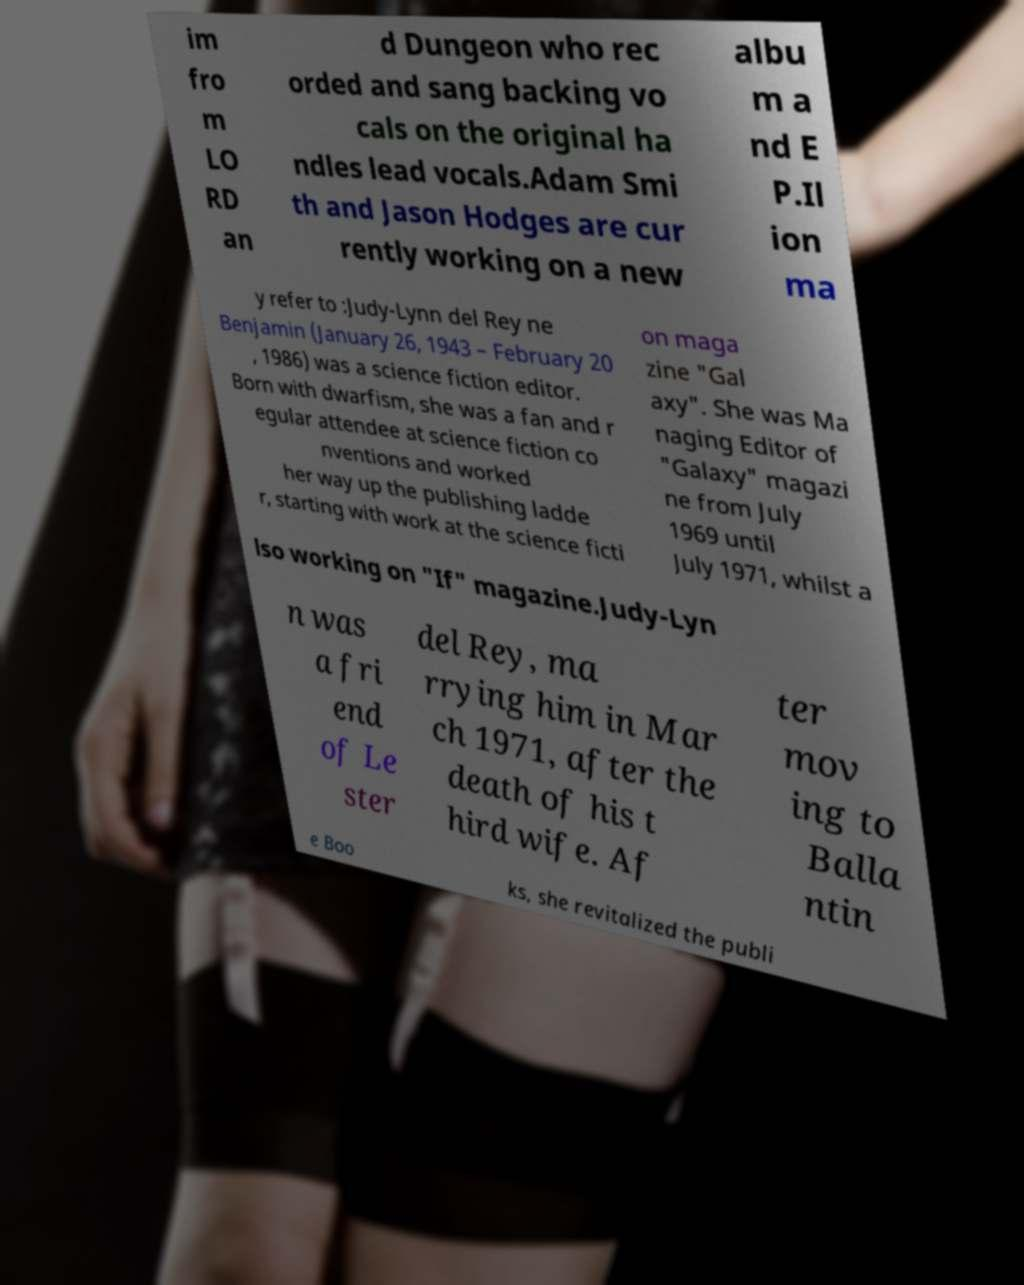Please identify and transcribe the text found in this image. im fro m LO RD an d Dungeon who rec orded and sang backing vo cals on the original ha ndles lead vocals.Adam Smi th and Jason Hodges are cur rently working on a new albu m a nd E P.Il ion ma y refer to :Judy-Lynn del Rey ne Benjamin (January 26, 1943 – February 20 , 1986) was a science fiction editor. Born with dwarfism, she was a fan and r egular attendee at science fiction co nventions and worked her way up the publishing ladde r, starting with work at the science ficti on maga zine "Gal axy". She was Ma naging Editor of "Galaxy" magazi ne from July 1969 until July 1971, whilst a lso working on "If" magazine.Judy-Lyn n was a fri end of Le ster del Rey, ma rrying him in Mar ch 1971, after the death of his t hird wife. Af ter mov ing to Balla ntin e Boo ks, she revitalized the publi 